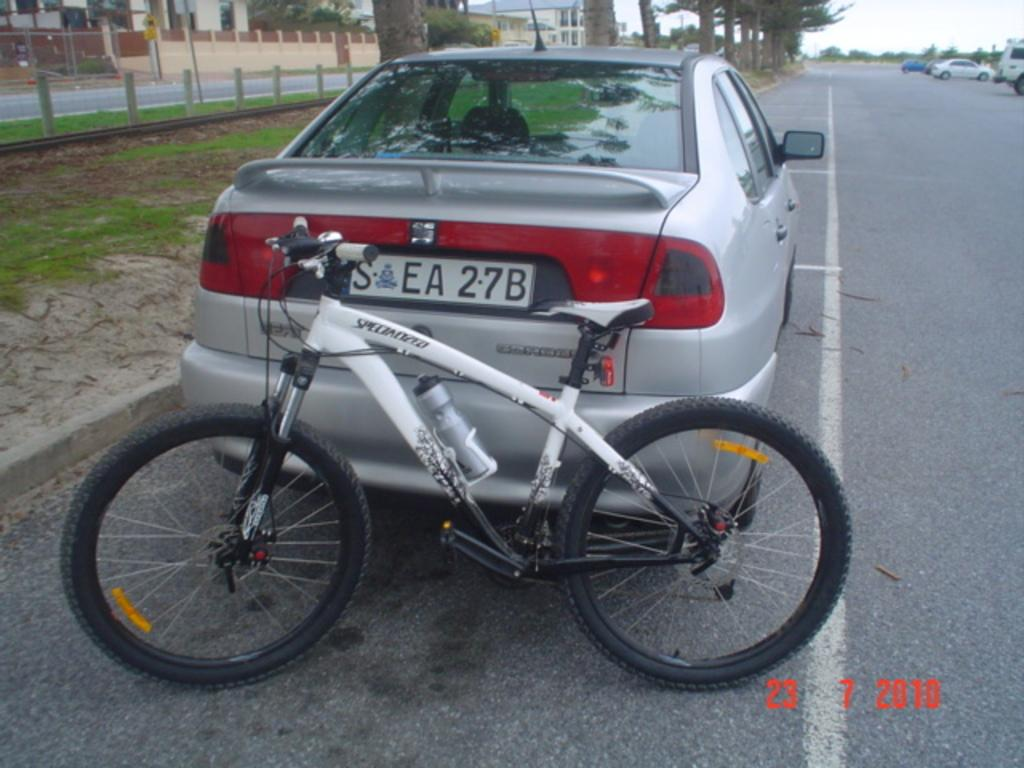What mode of transportation can be seen in the image? There is a bicycle in the image. What else is present on the road in the image? There are cars on the road in the image. What type of vegetation is visible beside the road? There are trees beside the road in the image. What architectural features can be seen in the image? There are pillars in the image. What type of ground cover is present in the image? There is grass in the image. What type of structures can be seen in the background of the image? There are houses in the background of the image. What type of waves can be seen crashing on the shore in the image? There are no waves or shore present in the image; it features a bicycle, cars, trees, pillars, grass, and houses. What part of the brain is visible in the image? There is no brain visible in the image; it features a bicycle, cars, trees, pillars, grass, and houses. 